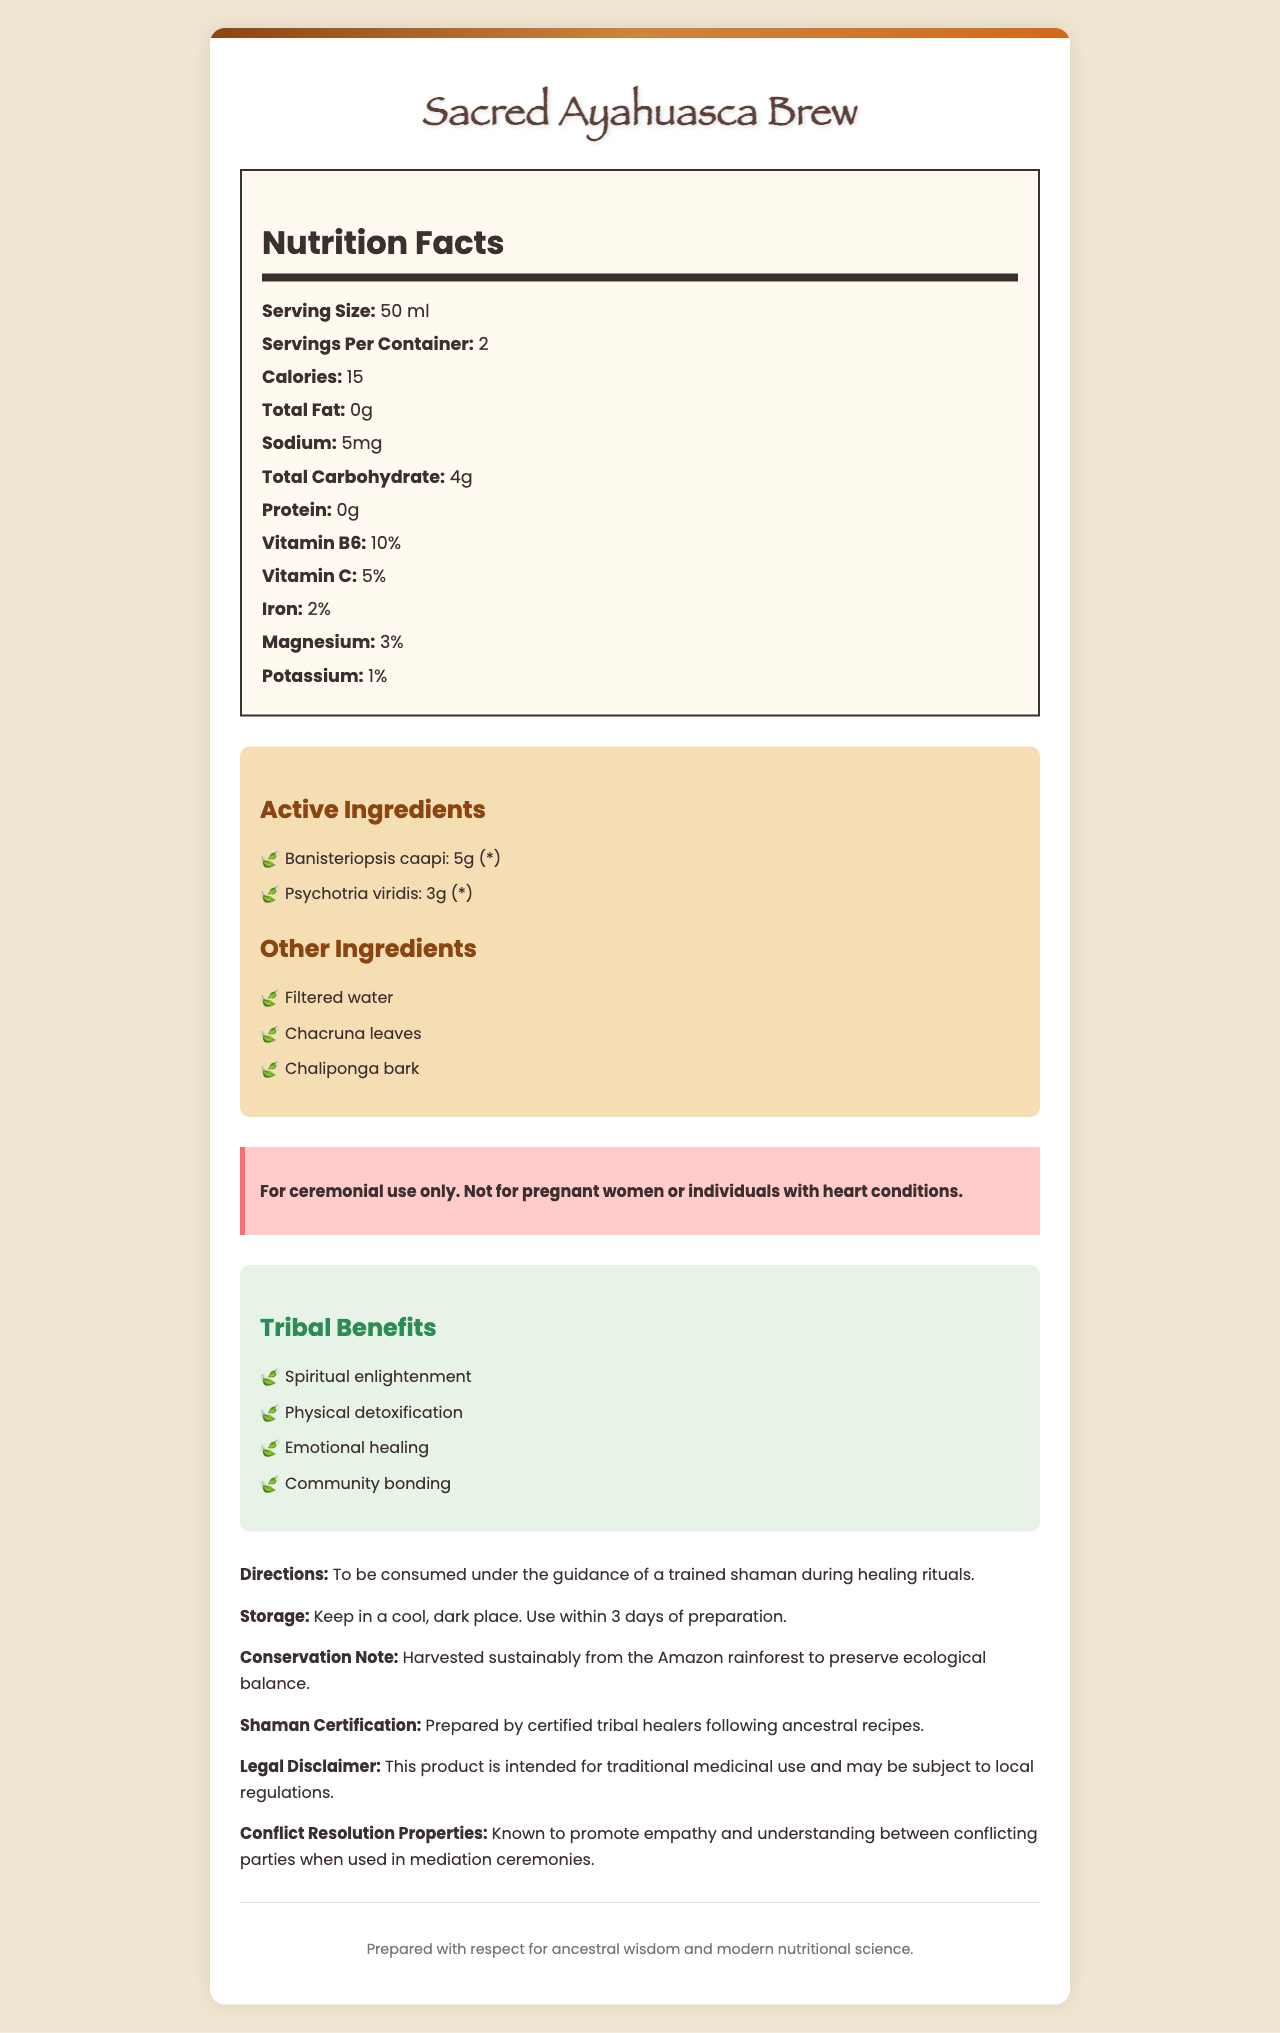what is the serving size of the Sacred Ayahuasca Brew? The document mentions "Serving Size: 50 ml" in the Nutrition Facts section.
Answer: 50 ml how many servings are there per container? The document mentions "Servings Per Container: 2" in the Nutrition Facts section.
Answer: 2 how many calories are in one serving of the Sacred Ayahuasca Brew? The document mentions "Calories: 15" in the Nutrition Facts section.
Answer: 15 what percentage of Vitamin B6 does one serving provide? The document mentions "Vitamin B6: 10%" in the Nutrition Facts section.
Answer: 10% name the two active ingredients in the Sacred Ayahuasca Brew. The document lists "Banisteriopsis caapi" and "Psychotria viridis" as the active ingredients in the ingredients section.
Answer: Banisteriopsis caapi and Psychotria viridis What are the other ingredients mentioned apart from the active ingredients? A. Filtered water, Chacruna leaves, Chaliponga bark B. Salt, Pepper, Sugar C. Vitamin A, Vitamin E, Zinc The document mentions "Filtered water, Chacruna leaves, Chaliponga bark" under the Other Ingredients section.
Answer: A how much sodium is in a single serving of this brew? A. 0mg B. 5mg C. 10mg The document mentions "Sodium: 5mg" in the Nutrition Facts section.
Answer: B is this product safe for pregnant women? The document has a warning that states, "Not for pregnant women or individuals with heart conditions."
Answer: No is the Sacred Ayahuasca Brew intended for daily consumption? The document states, "For ceremonial use only," indicating it is not for daily consumption.
Answer: No summarize the main idea of the Sacred Ayahuasca Brew document. The document is a detailed label for the Sacred Ayahuasca Brew, highlighting its nutritional facts, ingredients, warnings, usage directions, and the benefits it offers for tribal healing practices. It underscores the brew's role in spiritual and emotional healing, as well as its sustainable harvesting and preparation by certified tribal healers.
Answer: The Sacred Ayahuasca Brew document provides nutritional information, ingredients, warnings, directions, storage details, tribal benefits, conservation notes, shaman certification, and legal disclaimers for a ceremonial ayahuasca brew used for spiritual, physical, and emotional healing practices within tribal settings. It emphasizes the brew's traditional use, the involvement of certified tribal healers, and its conflict resolution properties. what is the spiritual benefit mentioned for using this brew? The document lists "Spiritual enlightenment" as one of the tribal benefits.
Answer: Spiritual enlightenment where should you store the Sacred Ayahuasca Brew once prepared? The document mentions "Keep in a cool, dark place. Use within 3 days of preparation" under the Storage section.
Answer: In a cool, dark place and use within 3 days of preparation what potential benefit does this brew have in resolving conflicts between parties? The document states that the brew is "Known to promote empathy and understanding between conflicting parties when used in mediation ceremonies."
Answer: Promotes empathy and understanding could the brew be harmful to individuals with heart conditions? The document explicitly warns, "Not for pregnant women or individuals with heart conditions."
Answer: Yes what is the conservation note associated with the Sacred Ayahuasca Brew? The document mentions this under the Conservation Note section.
Answer: Harvested sustainably from the Amazon rainforest to preserve ecological balance. are there detailed preparation instructions for making the brew mentioned in the document? The document provides consumption instructions but does not include detailed preparation instructions; it only mentions that it should be consumed under the guidance of a trained shaman.
Answer: Not enough information 